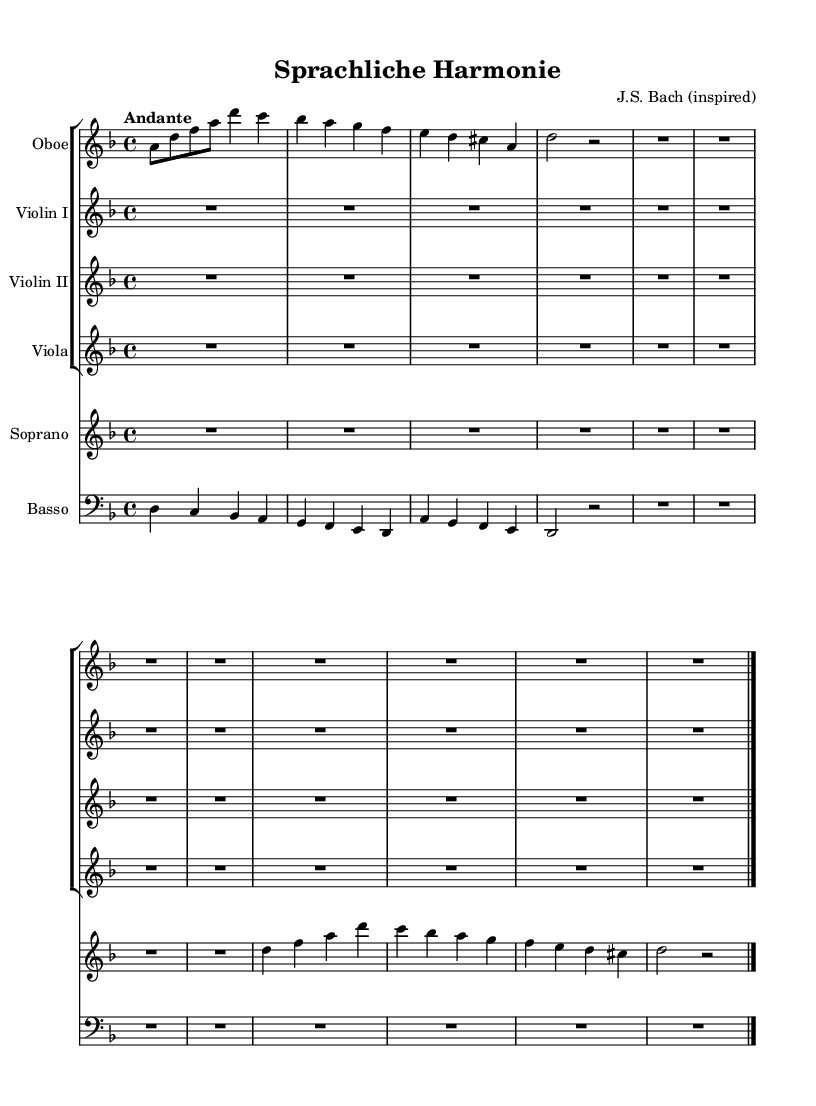What is the key signature of this music? The key signature is indicated by the number of sharps or flats at the start of the staff. In this piece, it shows one flat, which indicates D minor.
Answer: D minor What is the time signature of the piece? The time signature is displayed at the beginning of the music and indicates how many beats are in a measure. Here, it shows 4 over 4, meaning four beats per measure.
Answer: 4/4 What is the tempo marking provided? The tempo marking, which is often shown above the staff, indicates the speed of the music. Here, the term "Andante" is used, which suggests a moderately slow pace.
Answer: Andante What instruments are featured in this piece? The instruments are typically listed at the start of each staff, where each instrument’s name is written. This score includes Oboe, Violin I, Violin II, Viola, Soprano, and Basso.
Answer: Oboe, Violin I, Violin II, Viola, Soprano, Basso What literary theme is explored in the lyrics? The lyrics explicitly mention "Spra--che, Klang und Har--mo--nie," which highlights themes of language, sound, and harmony. The theme primarily revolves around communication through these elements.
Answer: Language, sound, and harmony How many parts are there for the strings? The score shows two violin parts, one viola, and an oboe, indicating multiple string parts. Adding these together gives a total of four parts for the strings.
Answer: Four parts What is the overall harmonic structure indicated by the bass part? The bass part outlines the fundamental notes that support the harmonic framework of the cantata. It progresses in a pattern that affirms the key and supports the other instrumental parts, establishing a foundation.
Answer: Harmonic foundation 